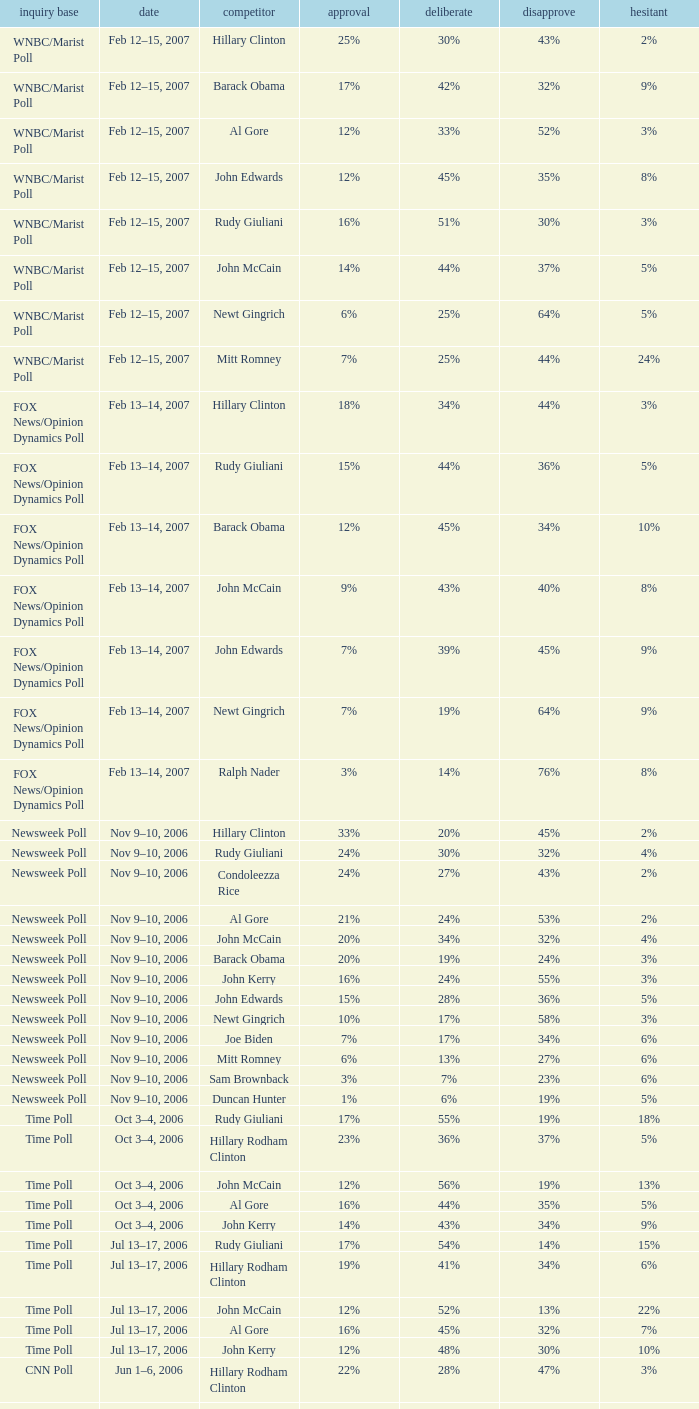What percentage of people were opposed to the candidate based on the Time Poll poll that showed 6% of people were unsure? 34%. 